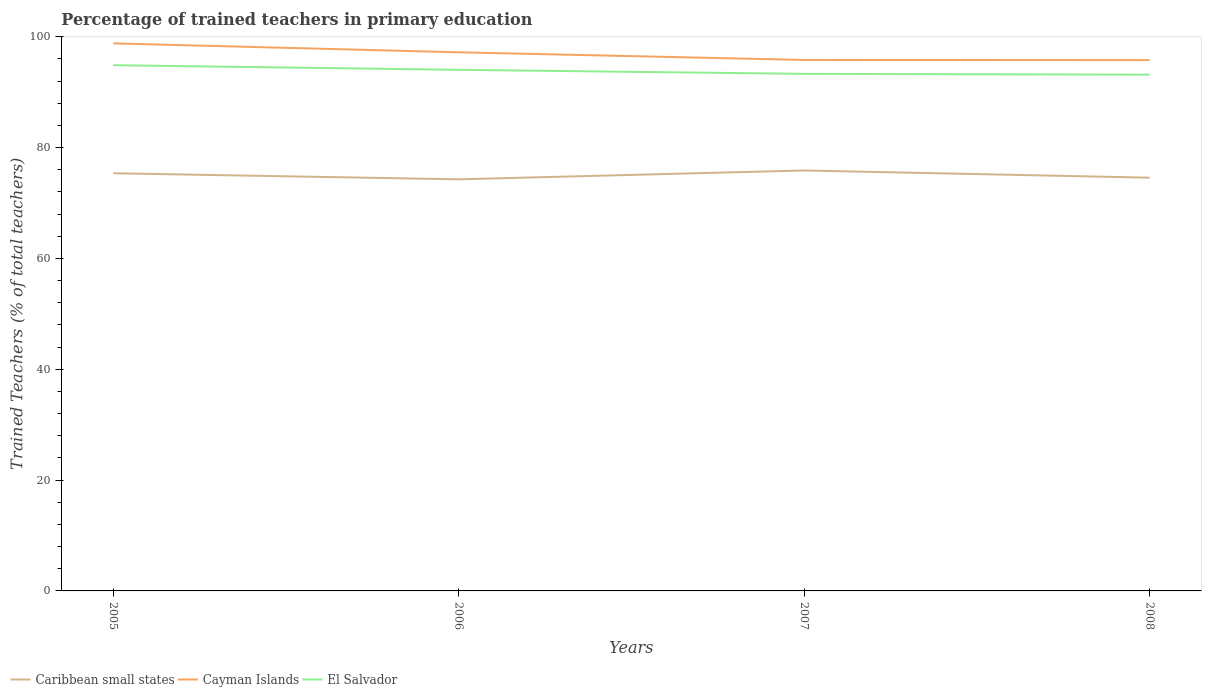Across all years, what is the maximum percentage of trained teachers in El Salvador?
Keep it short and to the point. 93.16. What is the total percentage of trained teachers in El Salvador in the graph?
Offer a very short reply. 0.73. What is the difference between the highest and the second highest percentage of trained teachers in Cayman Islands?
Offer a very short reply. 3.02. What is the difference between the highest and the lowest percentage of trained teachers in El Salvador?
Your response must be concise. 2. What is the difference between two consecutive major ticks on the Y-axis?
Ensure brevity in your answer.  20. Are the values on the major ticks of Y-axis written in scientific E-notation?
Keep it short and to the point. No. Where does the legend appear in the graph?
Ensure brevity in your answer.  Bottom left. How many legend labels are there?
Your answer should be very brief. 3. What is the title of the graph?
Your answer should be very brief. Percentage of trained teachers in primary education. What is the label or title of the Y-axis?
Offer a very short reply. Trained Teachers (% of total teachers). What is the Trained Teachers (% of total teachers) of Caribbean small states in 2005?
Keep it short and to the point. 75.38. What is the Trained Teachers (% of total teachers) in Cayman Islands in 2005?
Your answer should be compact. 98.81. What is the Trained Teachers (% of total teachers) of El Salvador in 2005?
Provide a succinct answer. 94.87. What is the Trained Teachers (% of total teachers) of Caribbean small states in 2006?
Offer a very short reply. 74.28. What is the Trained Teachers (% of total teachers) of Cayman Islands in 2006?
Offer a very short reply. 97.2. What is the Trained Teachers (% of total teachers) of El Salvador in 2006?
Provide a short and direct response. 94.04. What is the Trained Teachers (% of total teachers) of Caribbean small states in 2007?
Your answer should be very brief. 75.88. What is the Trained Teachers (% of total teachers) of Cayman Islands in 2007?
Your response must be concise. 95.82. What is the Trained Teachers (% of total teachers) in El Salvador in 2007?
Provide a succinct answer. 93.31. What is the Trained Teachers (% of total teachers) in Caribbean small states in 2008?
Your response must be concise. 74.57. What is the Trained Teachers (% of total teachers) in Cayman Islands in 2008?
Provide a short and direct response. 95.79. What is the Trained Teachers (% of total teachers) in El Salvador in 2008?
Offer a very short reply. 93.16. Across all years, what is the maximum Trained Teachers (% of total teachers) of Caribbean small states?
Your response must be concise. 75.88. Across all years, what is the maximum Trained Teachers (% of total teachers) of Cayman Islands?
Give a very brief answer. 98.81. Across all years, what is the maximum Trained Teachers (% of total teachers) in El Salvador?
Your answer should be very brief. 94.87. Across all years, what is the minimum Trained Teachers (% of total teachers) in Caribbean small states?
Ensure brevity in your answer.  74.28. Across all years, what is the minimum Trained Teachers (% of total teachers) of Cayman Islands?
Offer a very short reply. 95.79. Across all years, what is the minimum Trained Teachers (% of total teachers) of El Salvador?
Keep it short and to the point. 93.16. What is the total Trained Teachers (% of total teachers) of Caribbean small states in the graph?
Provide a succinct answer. 300.11. What is the total Trained Teachers (% of total teachers) in Cayman Islands in the graph?
Give a very brief answer. 387.63. What is the total Trained Teachers (% of total teachers) of El Salvador in the graph?
Provide a succinct answer. 375.39. What is the difference between the Trained Teachers (% of total teachers) in Caribbean small states in 2005 and that in 2006?
Provide a short and direct response. 1.1. What is the difference between the Trained Teachers (% of total teachers) in Cayman Islands in 2005 and that in 2006?
Your response must be concise. 1.61. What is the difference between the Trained Teachers (% of total teachers) in El Salvador in 2005 and that in 2006?
Your answer should be compact. 0.83. What is the difference between the Trained Teachers (% of total teachers) in Caribbean small states in 2005 and that in 2007?
Your response must be concise. -0.5. What is the difference between the Trained Teachers (% of total teachers) of Cayman Islands in 2005 and that in 2007?
Provide a succinct answer. 2.99. What is the difference between the Trained Teachers (% of total teachers) of El Salvador in 2005 and that in 2007?
Give a very brief answer. 1.56. What is the difference between the Trained Teachers (% of total teachers) of Caribbean small states in 2005 and that in 2008?
Provide a short and direct response. 0.8. What is the difference between the Trained Teachers (% of total teachers) of Cayman Islands in 2005 and that in 2008?
Your answer should be very brief. 3.02. What is the difference between the Trained Teachers (% of total teachers) in El Salvador in 2005 and that in 2008?
Keep it short and to the point. 1.71. What is the difference between the Trained Teachers (% of total teachers) of Caribbean small states in 2006 and that in 2007?
Ensure brevity in your answer.  -1.6. What is the difference between the Trained Teachers (% of total teachers) of Cayman Islands in 2006 and that in 2007?
Provide a succinct answer. 1.38. What is the difference between the Trained Teachers (% of total teachers) in El Salvador in 2006 and that in 2007?
Your response must be concise. 0.73. What is the difference between the Trained Teachers (% of total teachers) in Caribbean small states in 2006 and that in 2008?
Give a very brief answer. -0.29. What is the difference between the Trained Teachers (% of total teachers) in Cayman Islands in 2006 and that in 2008?
Offer a very short reply. 1.41. What is the difference between the Trained Teachers (% of total teachers) of El Salvador in 2006 and that in 2008?
Your answer should be very brief. 0.88. What is the difference between the Trained Teachers (% of total teachers) in Caribbean small states in 2007 and that in 2008?
Provide a short and direct response. 1.3. What is the difference between the Trained Teachers (% of total teachers) in Cayman Islands in 2007 and that in 2008?
Your response must be concise. 0.03. What is the difference between the Trained Teachers (% of total teachers) in El Salvador in 2007 and that in 2008?
Ensure brevity in your answer.  0.15. What is the difference between the Trained Teachers (% of total teachers) of Caribbean small states in 2005 and the Trained Teachers (% of total teachers) of Cayman Islands in 2006?
Your response must be concise. -21.83. What is the difference between the Trained Teachers (% of total teachers) in Caribbean small states in 2005 and the Trained Teachers (% of total teachers) in El Salvador in 2006?
Provide a succinct answer. -18.67. What is the difference between the Trained Teachers (% of total teachers) of Cayman Islands in 2005 and the Trained Teachers (% of total teachers) of El Salvador in 2006?
Your answer should be compact. 4.77. What is the difference between the Trained Teachers (% of total teachers) of Caribbean small states in 2005 and the Trained Teachers (% of total teachers) of Cayman Islands in 2007?
Your response must be concise. -20.45. What is the difference between the Trained Teachers (% of total teachers) of Caribbean small states in 2005 and the Trained Teachers (% of total teachers) of El Salvador in 2007?
Your answer should be very brief. -17.94. What is the difference between the Trained Teachers (% of total teachers) in Cayman Islands in 2005 and the Trained Teachers (% of total teachers) in El Salvador in 2007?
Offer a very short reply. 5.5. What is the difference between the Trained Teachers (% of total teachers) of Caribbean small states in 2005 and the Trained Teachers (% of total teachers) of Cayman Islands in 2008?
Ensure brevity in your answer.  -20.42. What is the difference between the Trained Teachers (% of total teachers) of Caribbean small states in 2005 and the Trained Teachers (% of total teachers) of El Salvador in 2008?
Give a very brief answer. -17.79. What is the difference between the Trained Teachers (% of total teachers) in Cayman Islands in 2005 and the Trained Teachers (% of total teachers) in El Salvador in 2008?
Keep it short and to the point. 5.65. What is the difference between the Trained Teachers (% of total teachers) in Caribbean small states in 2006 and the Trained Teachers (% of total teachers) in Cayman Islands in 2007?
Ensure brevity in your answer.  -21.54. What is the difference between the Trained Teachers (% of total teachers) in Caribbean small states in 2006 and the Trained Teachers (% of total teachers) in El Salvador in 2007?
Give a very brief answer. -19.03. What is the difference between the Trained Teachers (% of total teachers) of Cayman Islands in 2006 and the Trained Teachers (% of total teachers) of El Salvador in 2007?
Your answer should be very brief. 3.89. What is the difference between the Trained Teachers (% of total teachers) of Caribbean small states in 2006 and the Trained Teachers (% of total teachers) of Cayman Islands in 2008?
Your answer should be compact. -21.51. What is the difference between the Trained Teachers (% of total teachers) of Caribbean small states in 2006 and the Trained Teachers (% of total teachers) of El Salvador in 2008?
Give a very brief answer. -18.88. What is the difference between the Trained Teachers (% of total teachers) of Cayman Islands in 2006 and the Trained Teachers (% of total teachers) of El Salvador in 2008?
Offer a very short reply. 4.04. What is the difference between the Trained Teachers (% of total teachers) of Caribbean small states in 2007 and the Trained Teachers (% of total teachers) of Cayman Islands in 2008?
Offer a very short reply. -19.91. What is the difference between the Trained Teachers (% of total teachers) of Caribbean small states in 2007 and the Trained Teachers (% of total teachers) of El Salvador in 2008?
Provide a short and direct response. -17.29. What is the difference between the Trained Teachers (% of total teachers) in Cayman Islands in 2007 and the Trained Teachers (% of total teachers) in El Salvador in 2008?
Offer a very short reply. 2.66. What is the average Trained Teachers (% of total teachers) of Caribbean small states per year?
Give a very brief answer. 75.03. What is the average Trained Teachers (% of total teachers) in Cayman Islands per year?
Ensure brevity in your answer.  96.91. What is the average Trained Teachers (% of total teachers) in El Salvador per year?
Offer a terse response. 93.85. In the year 2005, what is the difference between the Trained Teachers (% of total teachers) in Caribbean small states and Trained Teachers (% of total teachers) in Cayman Islands?
Your answer should be very brief. -23.44. In the year 2005, what is the difference between the Trained Teachers (% of total teachers) of Caribbean small states and Trained Teachers (% of total teachers) of El Salvador?
Provide a succinct answer. -19.5. In the year 2005, what is the difference between the Trained Teachers (% of total teachers) in Cayman Islands and Trained Teachers (% of total teachers) in El Salvador?
Your response must be concise. 3.94. In the year 2006, what is the difference between the Trained Teachers (% of total teachers) in Caribbean small states and Trained Teachers (% of total teachers) in Cayman Islands?
Ensure brevity in your answer.  -22.92. In the year 2006, what is the difference between the Trained Teachers (% of total teachers) of Caribbean small states and Trained Teachers (% of total teachers) of El Salvador?
Your answer should be very brief. -19.76. In the year 2006, what is the difference between the Trained Teachers (% of total teachers) in Cayman Islands and Trained Teachers (% of total teachers) in El Salvador?
Offer a very short reply. 3.16. In the year 2007, what is the difference between the Trained Teachers (% of total teachers) in Caribbean small states and Trained Teachers (% of total teachers) in Cayman Islands?
Provide a short and direct response. -19.94. In the year 2007, what is the difference between the Trained Teachers (% of total teachers) of Caribbean small states and Trained Teachers (% of total teachers) of El Salvador?
Offer a terse response. -17.44. In the year 2007, what is the difference between the Trained Teachers (% of total teachers) in Cayman Islands and Trained Teachers (% of total teachers) in El Salvador?
Your answer should be very brief. 2.51. In the year 2008, what is the difference between the Trained Teachers (% of total teachers) in Caribbean small states and Trained Teachers (% of total teachers) in Cayman Islands?
Your answer should be compact. -21.22. In the year 2008, what is the difference between the Trained Teachers (% of total teachers) in Caribbean small states and Trained Teachers (% of total teachers) in El Salvador?
Provide a short and direct response. -18.59. In the year 2008, what is the difference between the Trained Teachers (% of total teachers) of Cayman Islands and Trained Teachers (% of total teachers) of El Salvador?
Provide a short and direct response. 2.63. What is the ratio of the Trained Teachers (% of total teachers) of Caribbean small states in 2005 to that in 2006?
Your response must be concise. 1.01. What is the ratio of the Trained Teachers (% of total teachers) in Cayman Islands in 2005 to that in 2006?
Offer a very short reply. 1.02. What is the ratio of the Trained Teachers (% of total teachers) in El Salvador in 2005 to that in 2006?
Your answer should be compact. 1.01. What is the ratio of the Trained Teachers (% of total teachers) of Caribbean small states in 2005 to that in 2007?
Keep it short and to the point. 0.99. What is the ratio of the Trained Teachers (% of total teachers) in Cayman Islands in 2005 to that in 2007?
Ensure brevity in your answer.  1.03. What is the ratio of the Trained Teachers (% of total teachers) of El Salvador in 2005 to that in 2007?
Your response must be concise. 1.02. What is the ratio of the Trained Teachers (% of total teachers) of Caribbean small states in 2005 to that in 2008?
Offer a terse response. 1.01. What is the ratio of the Trained Teachers (% of total teachers) in Cayman Islands in 2005 to that in 2008?
Make the answer very short. 1.03. What is the ratio of the Trained Teachers (% of total teachers) of El Salvador in 2005 to that in 2008?
Offer a very short reply. 1.02. What is the ratio of the Trained Teachers (% of total teachers) in Caribbean small states in 2006 to that in 2007?
Keep it short and to the point. 0.98. What is the ratio of the Trained Teachers (% of total teachers) of Cayman Islands in 2006 to that in 2007?
Make the answer very short. 1.01. What is the ratio of the Trained Teachers (% of total teachers) in El Salvador in 2006 to that in 2007?
Ensure brevity in your answer.  1.01. What is the ratio of the Trained Teachers (% of total teachers) in Cayman Islands in 2006 to that in 2008?
Provide a succinct answer. 1.01. What is the ratio of the Trained Teachers (% of total teachers) of El Salvador in 2006 to that in 2008?
Your response must be concise. 1.01. What is the ratio of the Trained Teachers (% of total teachers) in Caribbean small states in 2007 to that in 2008?
Provide a short and direct response. 1.02. What is the ratio of the Trained Teachers (% of total teachers) in Cayman Islands in 2007 to that in 2008?
Your response must be concise. 1. What is the ratio of the Trained Teachers (% of total teachers) in El Salvador in 2007 to that in 2008?
Provide a short and direct response. 1. What is the difference between the highest and the second highest Trained Teachers (% of total teachers) of Caribbean small states?
Offer a terse response. 0.5. What is the difference between the highest and the second highest Trained Teachers (% of total teachers) in Cayman Islands?
Give a very brief answer. 1.61. What is the difference between the highest and the second highest Trained Teachers (% of total teachers) in El Salvador?
Offer a terse response. 0.83. What is the difference between the highest and the lowest Trained Teachers (% of total teachers) of Caribbean small states?
Keep it short and to the point. 1.6. What is the difference between the highest and the lowest Trained Teachers (% of total teachers) in Cayman Islands?
Ensure brevity in your answer.  3.02. What is the difference between the highest and the lowest Trained Teachers (% of total teachers) of El Salvador?
Provide a short and direct response. 1.71. 